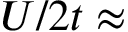<formula> <loc_0><loc_0><loc_500><loc_500>U / 2 t \approx</formula> 